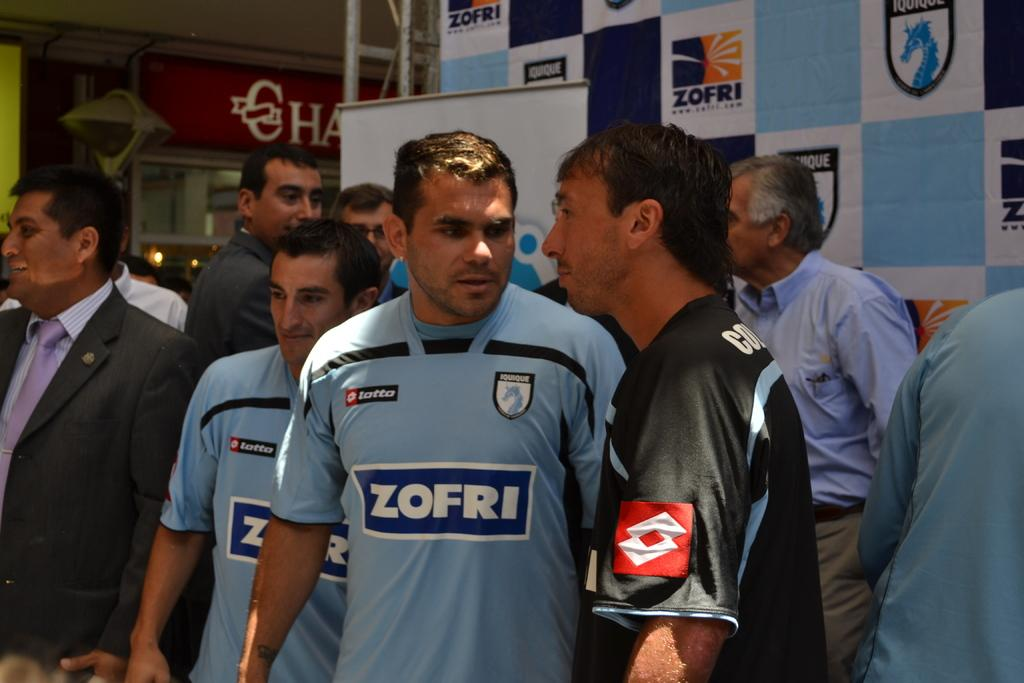<image>
Offer a succinct explanation of the picture presented. A group of men are wearing shirts that say Zofri and are in a shopping mall. 